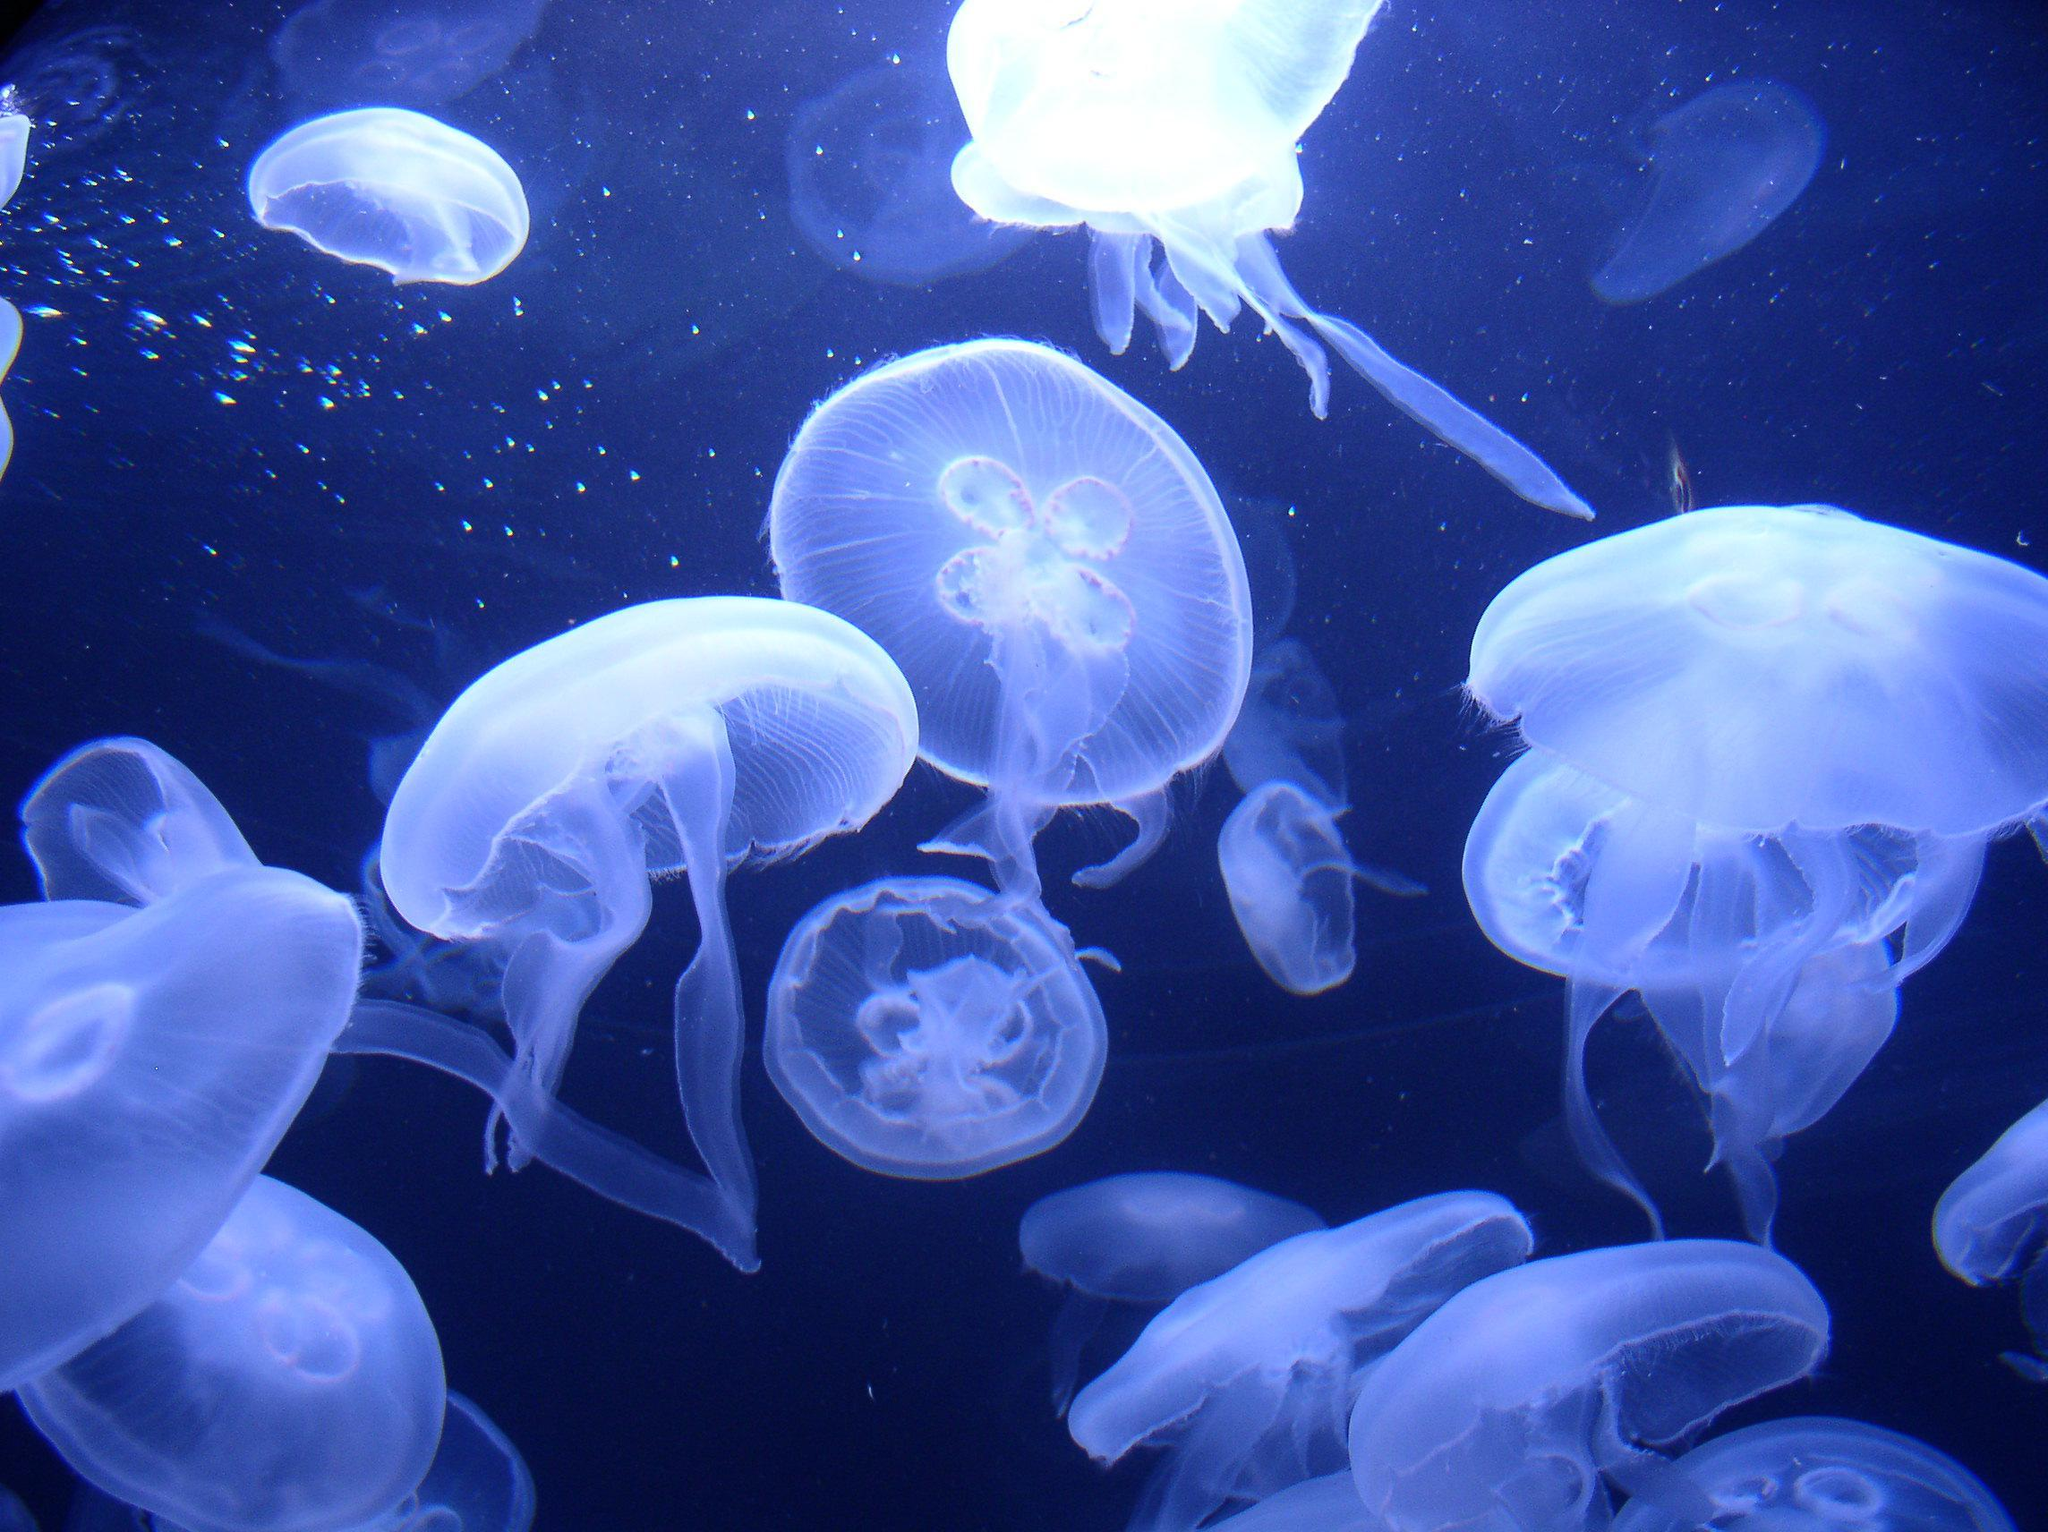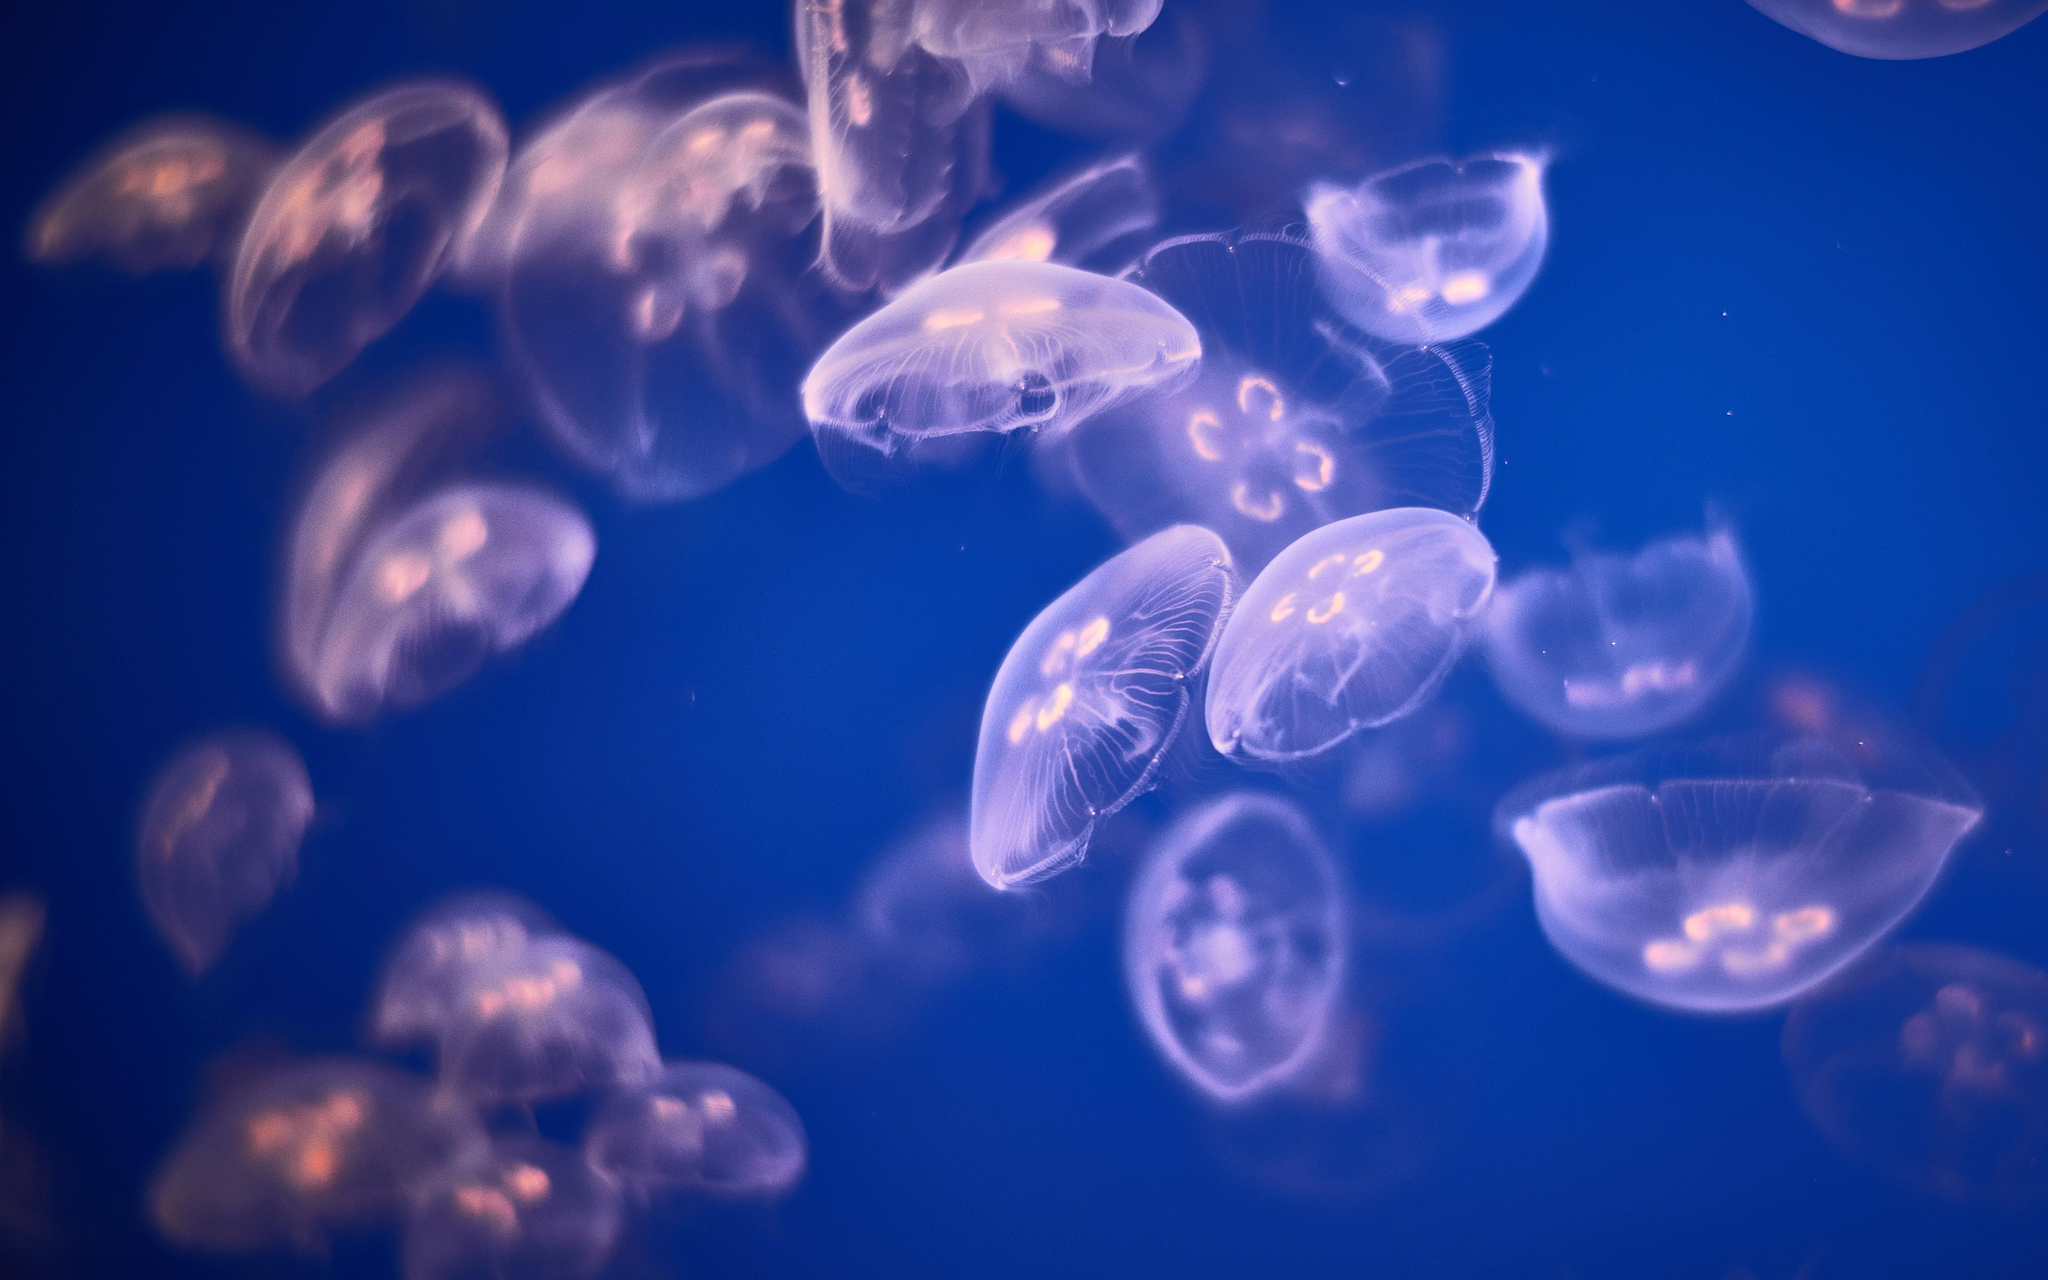The first image is the image on the left, the second image is the image on the right. Considering the images on both sides, is "Each image contains at least ten jellyfish, and no jellyfish have thread-like tentacles." valid? Answer yes or no. Yes. The first image is the image on the left, the second image is the image on the right. For the images displayed, is the sentence "There are more than twenty jellyfish." factually correct? Answer yes or no. Yes. 